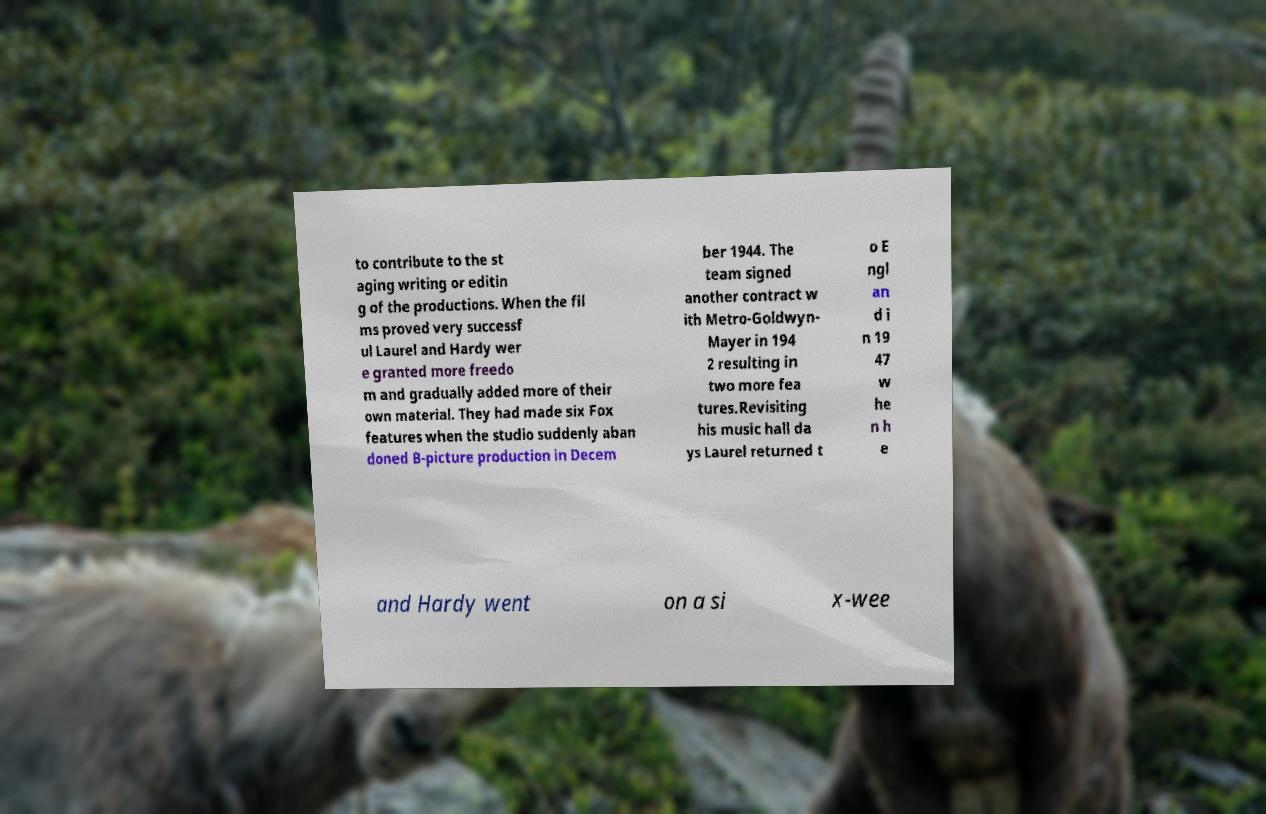Can you read and provide the text displayed in the image?This photo seems to have some interesting text. Can you extract and type it out for me? to contribute to the st aging writing or editin g of the productions. When the fil ms proved very successf ul Laurel and Hardy wer e granted more freedo m and gradually added more of their own material. They had made six Fox features when the studio suddenly aban doned B-picture production in Decem ber 1944. The team signed another contract w ith Metro-Goldwyn- Mayer in 194 2 resulting in two more fea tures.Revisiting his music hall da ys Laurel returned t o E ngl an d i n 19 47 w he n h e and Hardy went on a si x-wee 